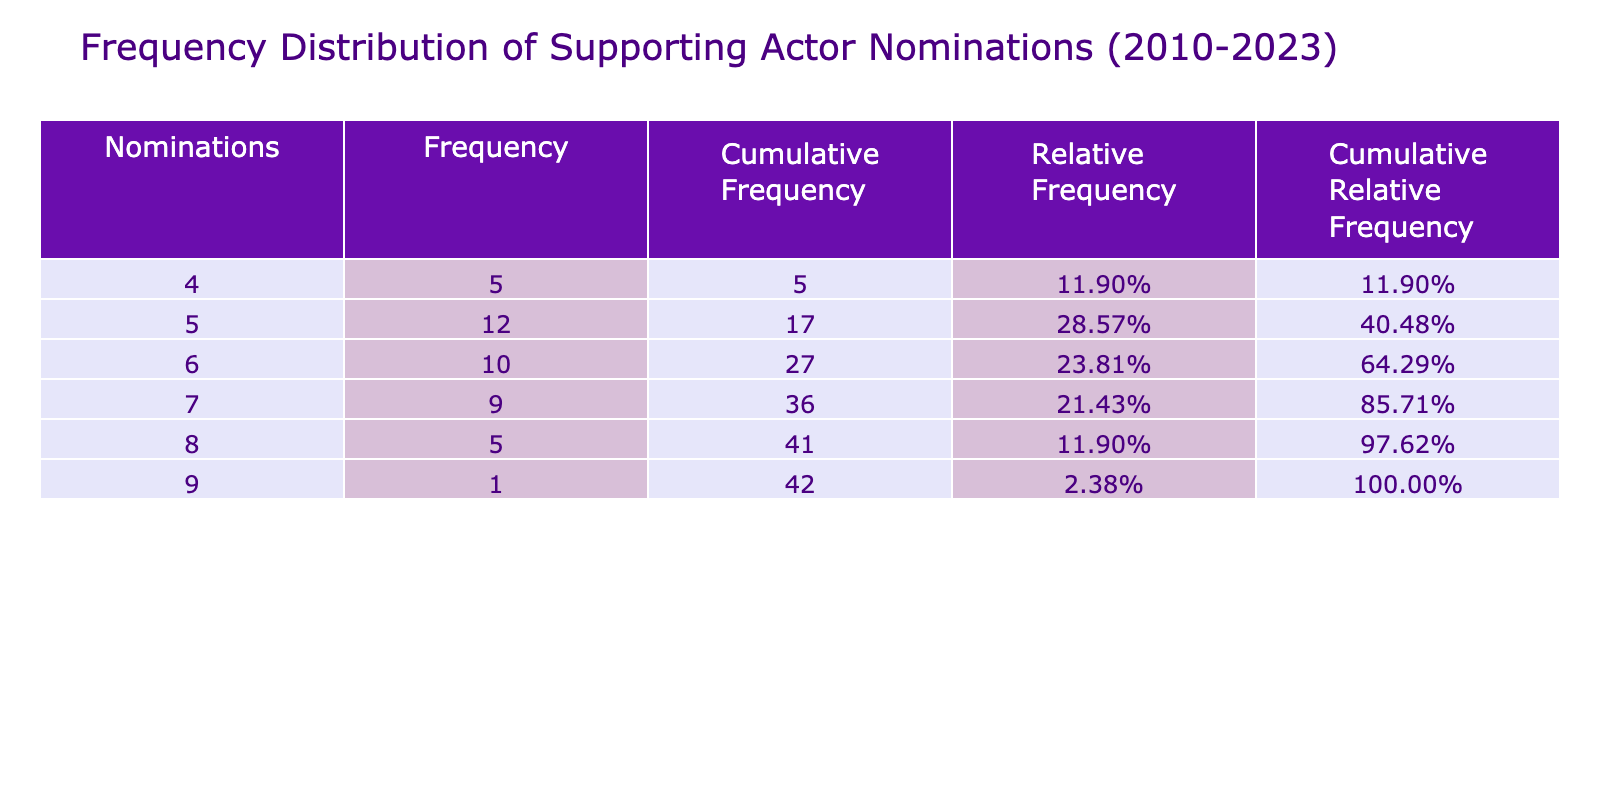What is the frequency of nominations for 5? Looking at the frequency distribution table, the value 5 appears in the nominations column. Summing the corresponding frequencies of nominations equal to 5, we see it appears 7 times across all considered years.
Answer: 7 What is the total number of nominations from 2010 to 2023? To find the total number of nominations, we can sum all the frequencies listed in the table. The frequencies are 5, 7, 6, 4, 8, 5, 5, 6, 7, 7, 5, 9, 6, 4, 6, 5, 8, 5, 4, 6, 5, 7, 5, 8, 6, 5, and 7. Summing those gives us 138.
Answer: 138 How many times were there nominations of 8? By checking the nominations column in the table, the value 8 appears in two instances. The corresponding frequencies show that nominations of 8 occurred a total of 3 times across the years.
Answer: 3 Is the highest number of nominations greater than 10? The highest number of nominations in the table is 9, as observed in the Golden Globe Awards for 2014. Because 9 is less than 10, we conclude that it is not greater than 10.
Answer: No What is the ratio of nominations for 6 to those for 4? We first count the frequencies for both nominations: there are 8 instances of 6 and 6 instances of 4. To find the ratio, we perform the calculation 8 divided by 6, resulting in approximately 1.33.
Answer: 1.33 What are the cumulative and relative frequencies for nominations of 7? From the table, we see that nominations of 7 occurred 6 times. The cumulative frequency for 7 includes the total of all frequencies before it, which is 23, leading us to determine that the relative frequency is 6 divided by the total number of nominations (138), which equals about 0.0435.
Answer: Cumulative: 23, Relative: 0.0435 In which year did the number of nominations equal the lowest value, and what was the value? On examining the table, we find that the lowest number of nominations is 4. This value appears in the years 2011, 2015, 2018, and 2021. Therefore, the answer acknowledges multiple years.
Answer: 2011, 2015, 2018, 2021; Value: 4 How many total awards considered nominations greater than 5? We review the nominations in the table and consider those greater than 5, which are 6, 7, 8, and 9. By summing their frequencies, we find the total of these frequencies is 76.
Answer: 76 What was the most frequent nomination value in the period from 2010 to 2023? Looking through the frequency distribution table, we identify the frequency values and find that 6 had the highest occurrence totaling 16 times.
Answer: 6 